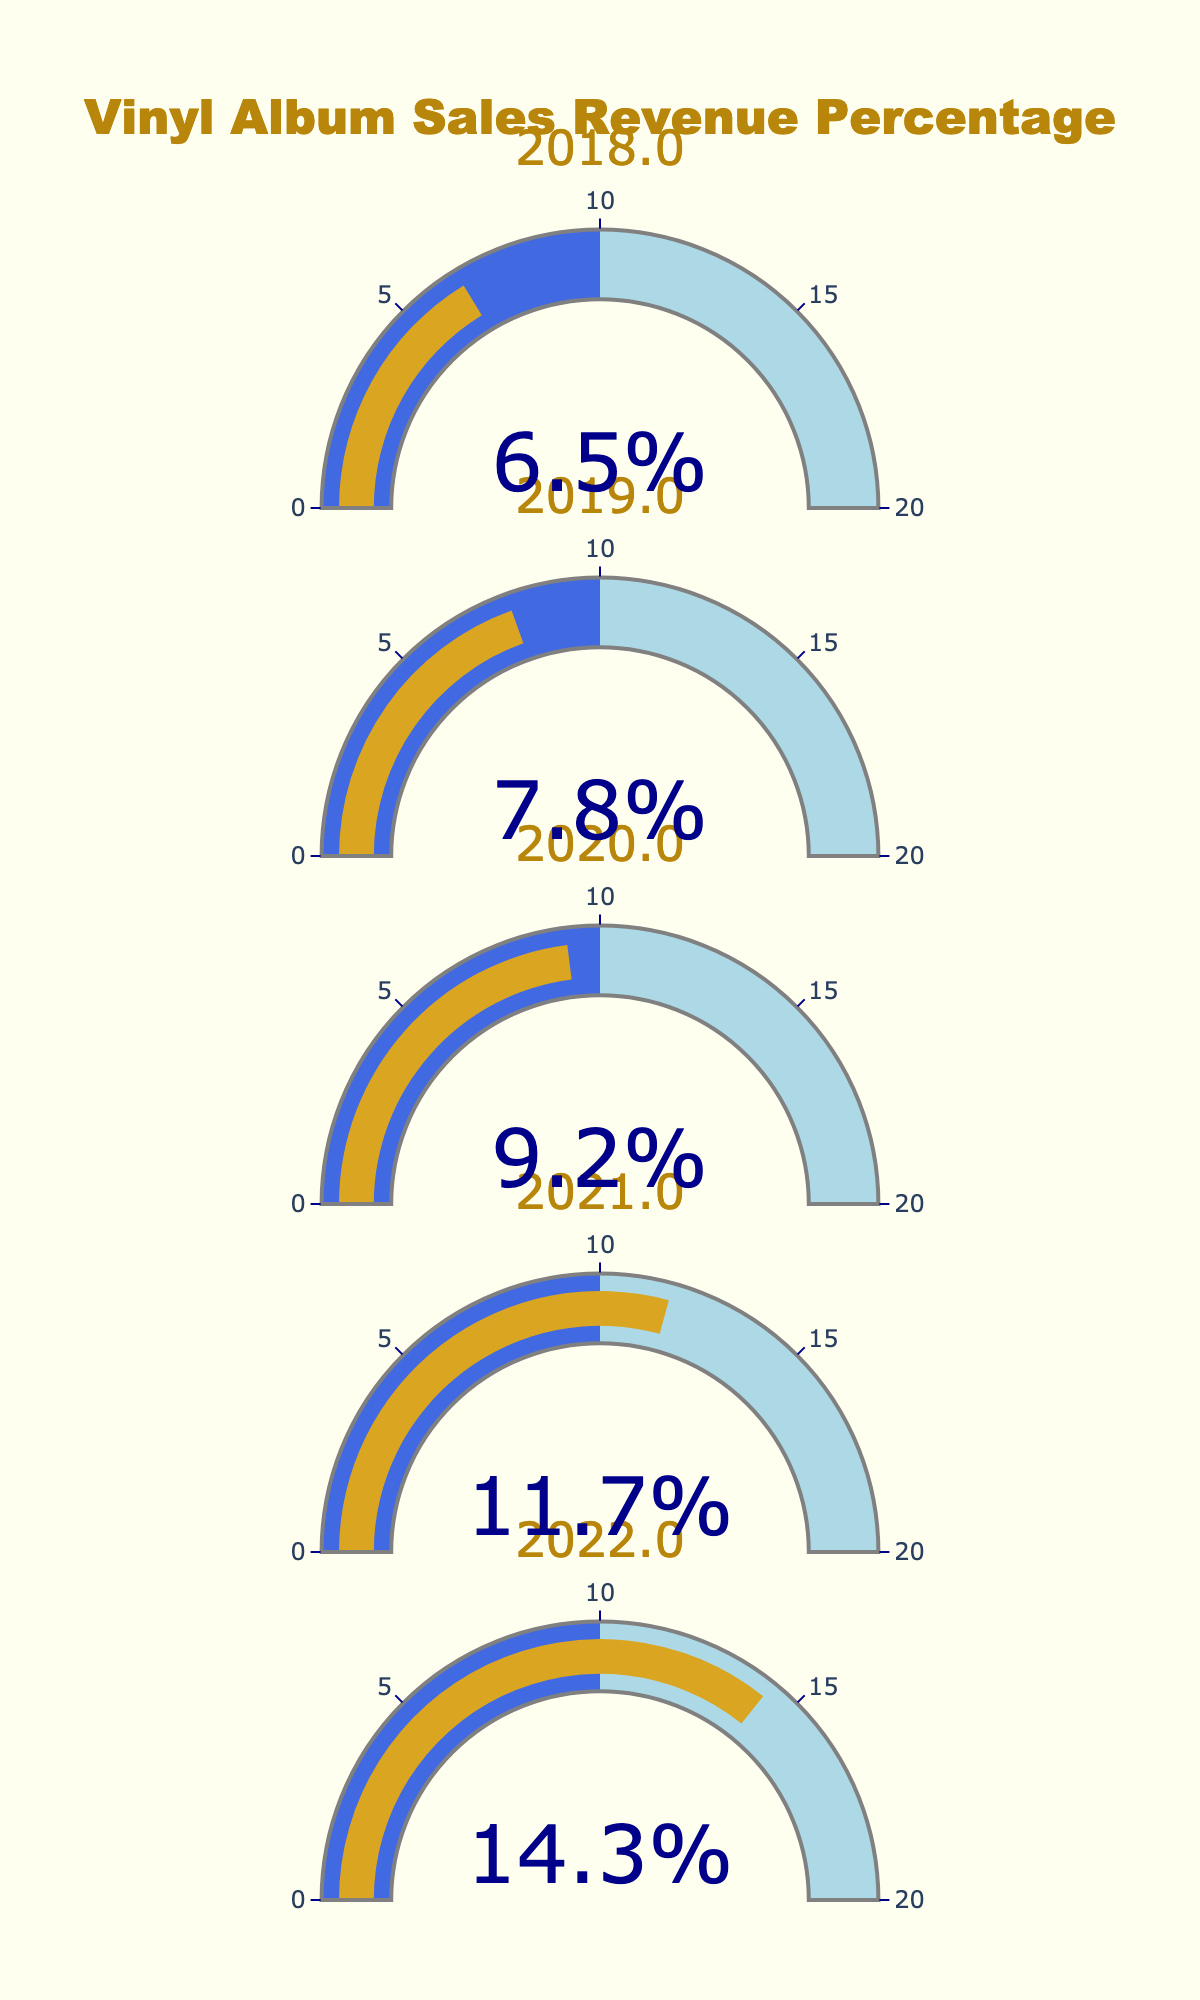What is the title of the figure? The title is located at the top center of the figure. It’s a straightforward piece of information that provides context to the visual data.
Answer: Vinyl Album Sales Revenue Percentage How many years are represented in the figure? To determine the number of years, count the distinct circular gauges in the figure. Each gauge represents a different year.
Answer: 5 What was the percentage of total revenue from vinyl album sales in 2019? Look at the gauge labeled "2019" and read the percentage value displayed in the center of the gauge.
Answer: 7.8% Which year had the highest percentage of total revenue from vinyl album sales? Compare the percentage values on each gauge. The highest value can be identified directly by inspection.
Answer: 2022 By how much did the percentage of revenue increase from 2018 to 2019? Subtract the percentage of 2018 from the percentage of 2019: 7.8% - 6.5% = 1.3%. The increase is the result of this subtraction.
Answer: 1.3% What is the average percentage of revenue from vinyl album sales over the years represented? Sum up all the percentages and then divide by the number of years: (14.3% + 11.7% + 9.2% + 7.8% + 6.5%) / 5.
Answer: 9.9% Which year had the smallest increase in percentage compared to the previous year? Calculate the increases for each year and compare them: 2021-2022 was 14.3% - 11.7% = 2.6%, 2020-2021 was 11.7% - 9.2% = 2.5%, 2019-2020 was 9.2% - 7.8% = 1.4%, and 2018-2019 was 7.8% - 6.5% = 1.3%. The smallest is 2019-2020 with 1.4%.
Answer: 2020 Is the percentage increase between 2021 and 2022 greater than the increase between 2019 and 2020? Calculate both increases: 2021-2022 is 14.3% - 11.7% = 2.6%, and 2019-2020 is 9.2% - 7.8% = 1.4%. Compare the results: 2.6% is greater than 1.4%.
Answer: Yes What is the percentage difference between the highest and lowest years presented? Subtract the lowest percentage (2018: 6.5%) from the highest percentage (2022: 14.3%): 14.3% - 6.5% = 7.8%.
Answer: 7.8% 